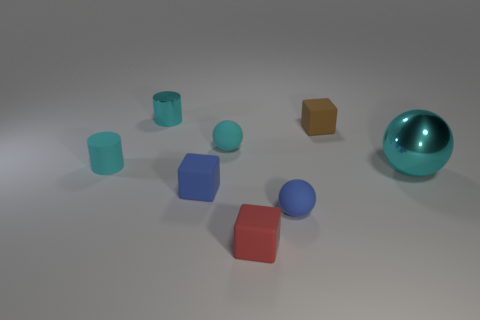Add 1 tiny brown rubber cubes. How many objects exist? 9 Subtract all cubes. How many objects are left? 5 Subtract 1 red cubes. How many objects are left? 7 Subtract all rubber balls. Subtract all small gray objects. How many objects are left? 6 Add 6 tiny cyan shiny objects. How many tiny cyan shiny objects are left? 7 Add 8 big blue metallic objects. How many big blue metallic objects exist? 8 